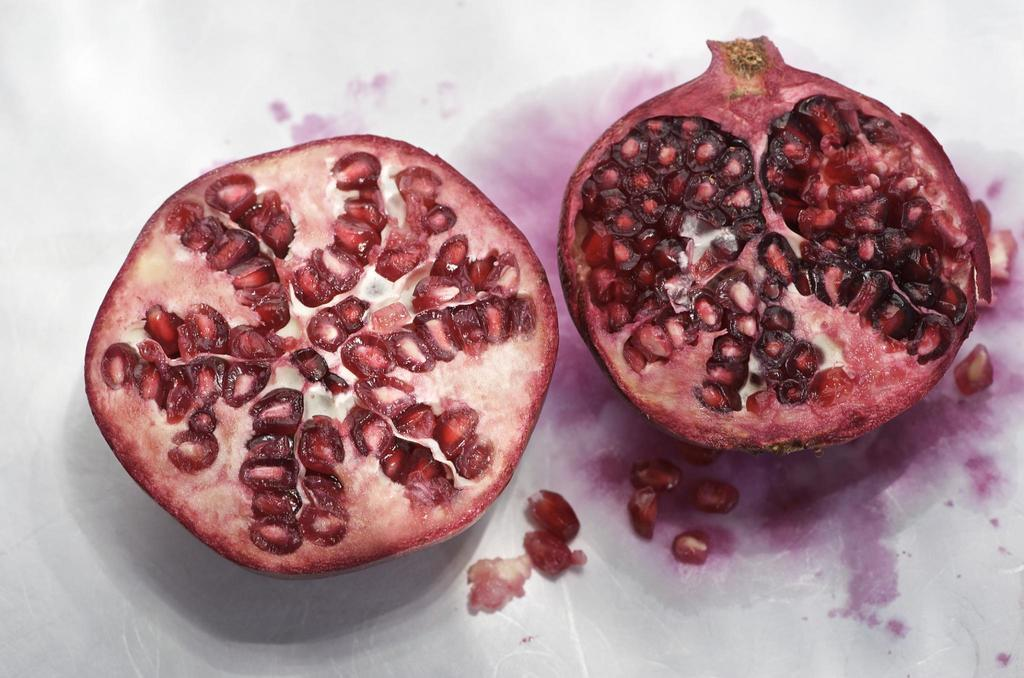What type of fruit is visible in the image? There are two pieces of a pomegranate in the image. Can you hear the pomegranate pieces laughing in the image? The pomegranate pieces do not make any sounds, including laughter, in the image. 